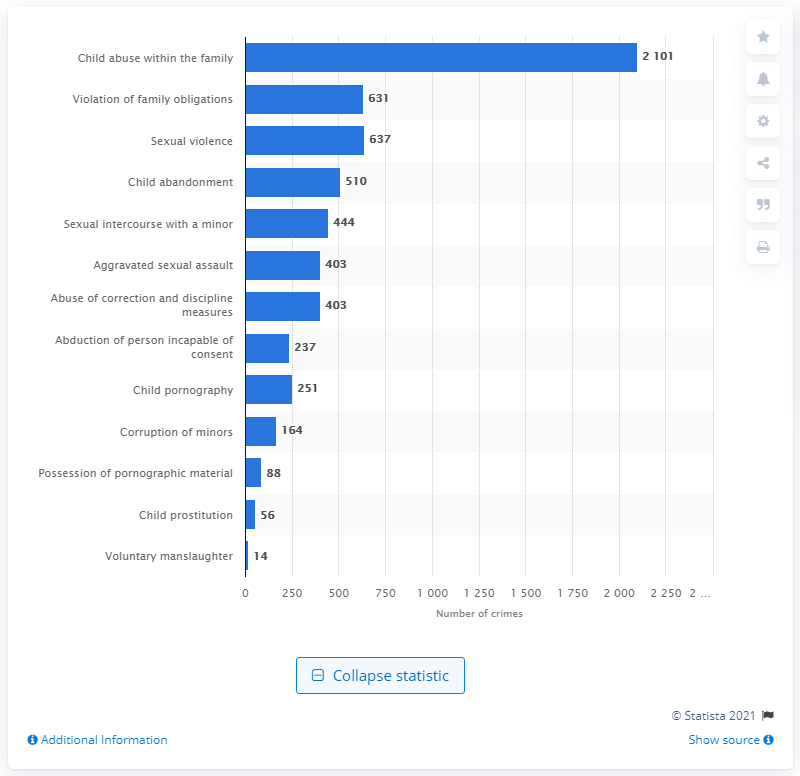Give some essential details in this illustration. In 2019, a total of 631 cases of family obligation violations were registered. According to the records, there were 510 cases of child abandonment in the same year. 